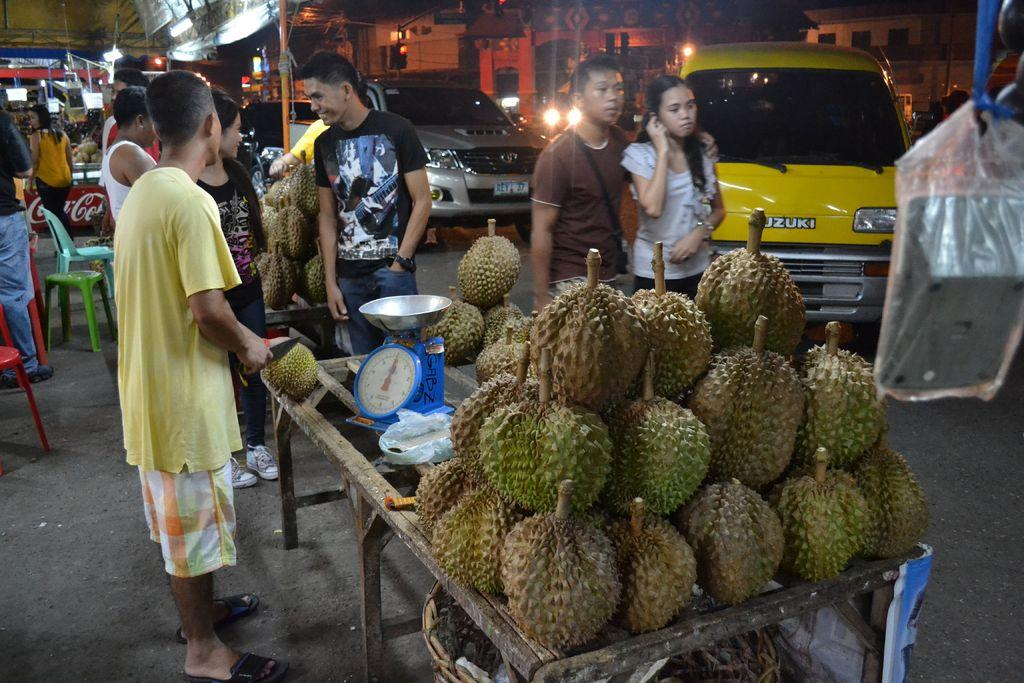What can be seen on the road in the image? There are vehicles on the road in the image. What is placed on the tables in the image? There are fruits placed on tables in the image. Who or what is visible in the image? There are people visible in the image. What can be seen in the distance in the image? There are buildings in the background of the image. Can you see any owls sitting on the fruits in the image? There are no owls present in the image; it features vehicles on the road, fruits on tables, people, and buildings in the background. What type of tooth is visible in the image? There is no tooth present in the image. 